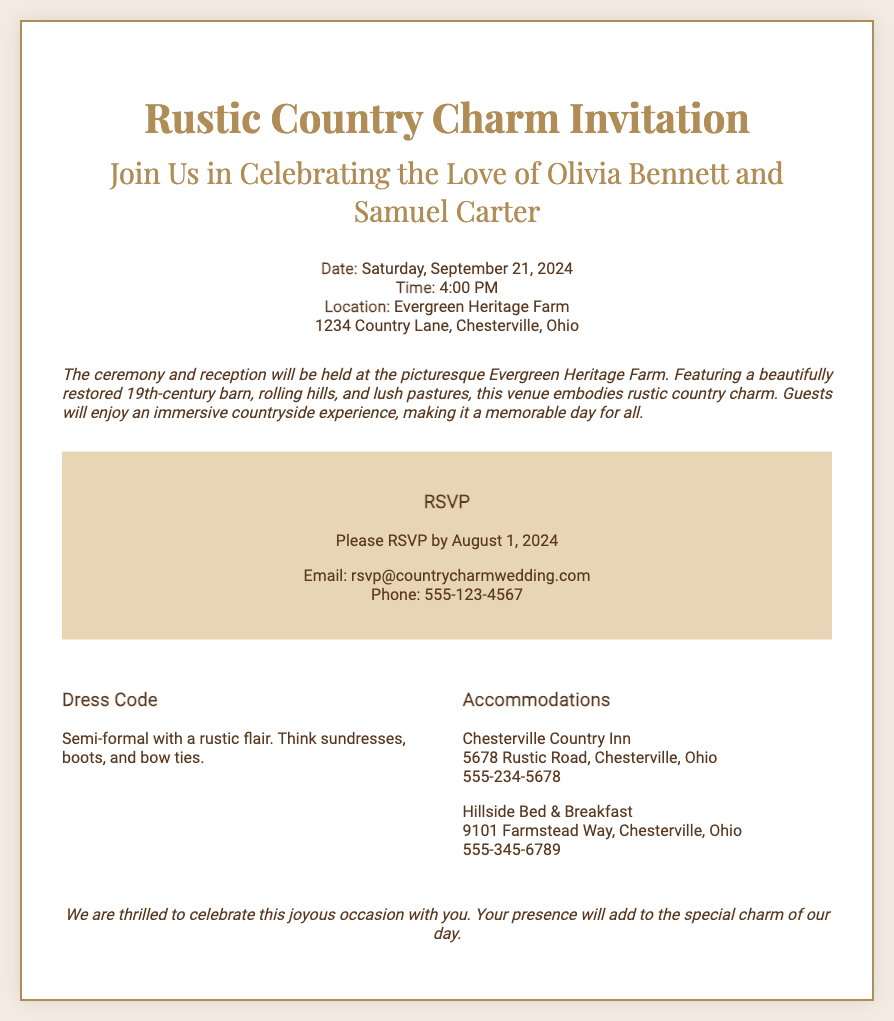What is the date of the wedding? The date of the wedding is specified in the document as Saturday, September 21, 2024.
Answer: September 21, 2024 What time does the ceremony start? The document states the ceremony will begin at 4:00 PM.
Answer: 4:00 PM Where is the wedding venue located? The venue location is provided in the invitation as Evergreen Heritage Farm, 1234 Country Lane, Chesterville, Ohio.
Answer: Evergreen Heritage Farm What is the dress code? The dress code detail is mentioned in the document as semi-formal with a rustic flair.
Answer: Semi-formal with a rustic flair By when should guests RSVP? The RSVP deadline is clearly indicated in the document as August 1, 2024.
Answer: August 1, 2024 What type of venue is featured for the wedding? The venue description describes it as a beautifully restored 19th-century barn.
Answer: Restored 19th-century barn Which two accommodations are listed? The document lists Chesterville Country Inn and Hillside Bed & Breakfast as accommodations.
Answer: Chesterville Country Inn and Hillside Bed & Breakfast What is the significance of the hosts' initials shown in the background? The initials "O&S" represent the couple’s names—Olivia and Samuel—highlighting their union.
Answer: O&S 